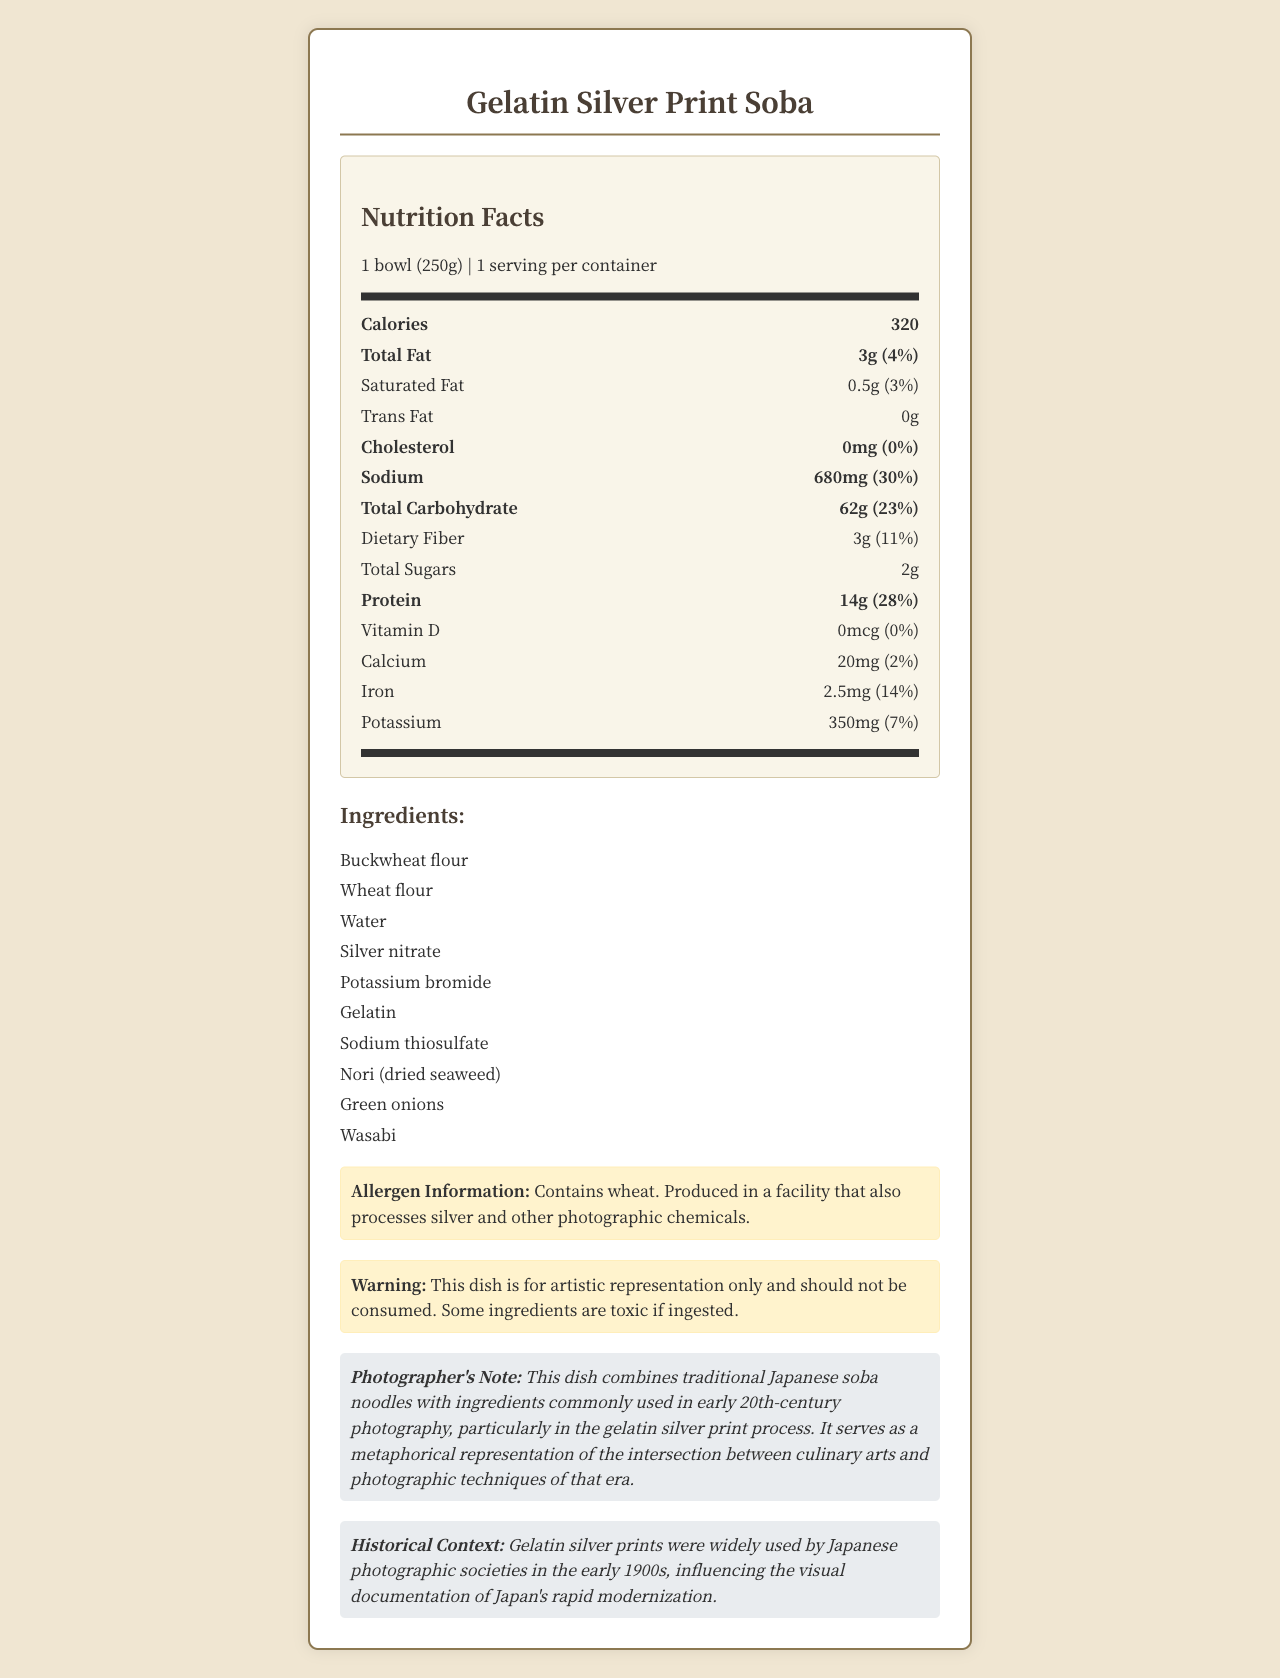what is the serving size for the "Gelatin Silver Print Soba"? The serving size is specified as "1 bowl (250g)" within the document.
Answer: 1 bowl (250g) how much sodium is in one serving? The sodium content per serving is listed as 680mg in the Nutrition Facts section.
Answer: 680mg does the dish contain any cholesterol? The document states the cholesterol content as "0mg" which means there is no cholesterol in the dish.
Answer: No what percentage of the daily value for protein is provided by one serving? The document lists the daily value for protein as "28%" for one serving.
Answer: 28% what is one of the main ingredients used in early 20th-century photography found in this dish? Gelatin is listed as one of the ingredients and it was commonly used in early 20th-century photographic processes.
Answer: Gelatin how many grams of total carbohydrate does the dish contain? The total carbohydrate content per serving is listed as 62g in the Nutrition Facts section.
Answer: 62g which of the following ingredients are NOT in the dish? A. Silver nitrate B. Tomatoes C. Green onions Tomatoes are not listed as an ingredient, while Silver nitrate and Green onions are.
Answer: B what is the historical context mentioned in the document? A. The dish was created as a popular food in the early 1900s in Japan B. Gelatin silver prints were influential in documenting Japan's modernization in the early 1900s C. Traditional Japanese dishes typically incorporated photographic chemicals The document states that "Gelatin silver prints were widely used by Japanese photographic societies in the early 1900s, influencing the visual documentation of Japan's rapid modernization."
Answer: B is this dish safe to eat? The document includes a warning that the dish is for artistic representation only and contains toxic ingredients if ingested.
Answer: No summarize the main purpose of this document. The document presents nutritional facts, ingredients, allergen information, and a warning, emphasizing that the dish is not meant for consumption. It highlights the dish's connection to historical photographic processes used by Japanese societies.
Answer: This document provides nutritional information for an artistic representation of a Japanese dish called "Gelatin Silver Print Soba," which incorporates early 20th-century photography ingredients to metaphorically explore the intersection of culinary arts and photographic techniques. what is the daily value percentage of iron provided by one serving? The daily value percentage for iron is listed as "14%" in the Nutrition Facts.
Answer: 14% how many grams of total fat does the dish contain? The total fat content per serving is listed as 3g in the Nutrition Facts section.
Answer: 3g what ingredient in the dish is used for developing photographs? Sodium thiosulfate is listed in the ingredients and is known for its use in the photographic development process.
Answer: Sodium thiosulfate what does the document say about the facility where this dish is produced? The allergen information states that the dish is produced in a facility that handles silver and other photographic chemicals.
Answer: Produced in a facility that also processes silver and other photographic chemicals what is the intended message of the photographer's note? The photographer's note explains that the dish is a metaphorical representation of the convergence of culinary and photographic arts.
Answer: The dish combines traditional Japanese soba noodles with ingredients used in early 20th-century photography to symbolize the intersection between culinary arts and photographic techniques. what are some health benefits of consuming this dish? The document clearly states that the dish is not meant for consumption and contains toxic ingredients, so we cannot determine any health benefits.
Answer: Cannot be determined 